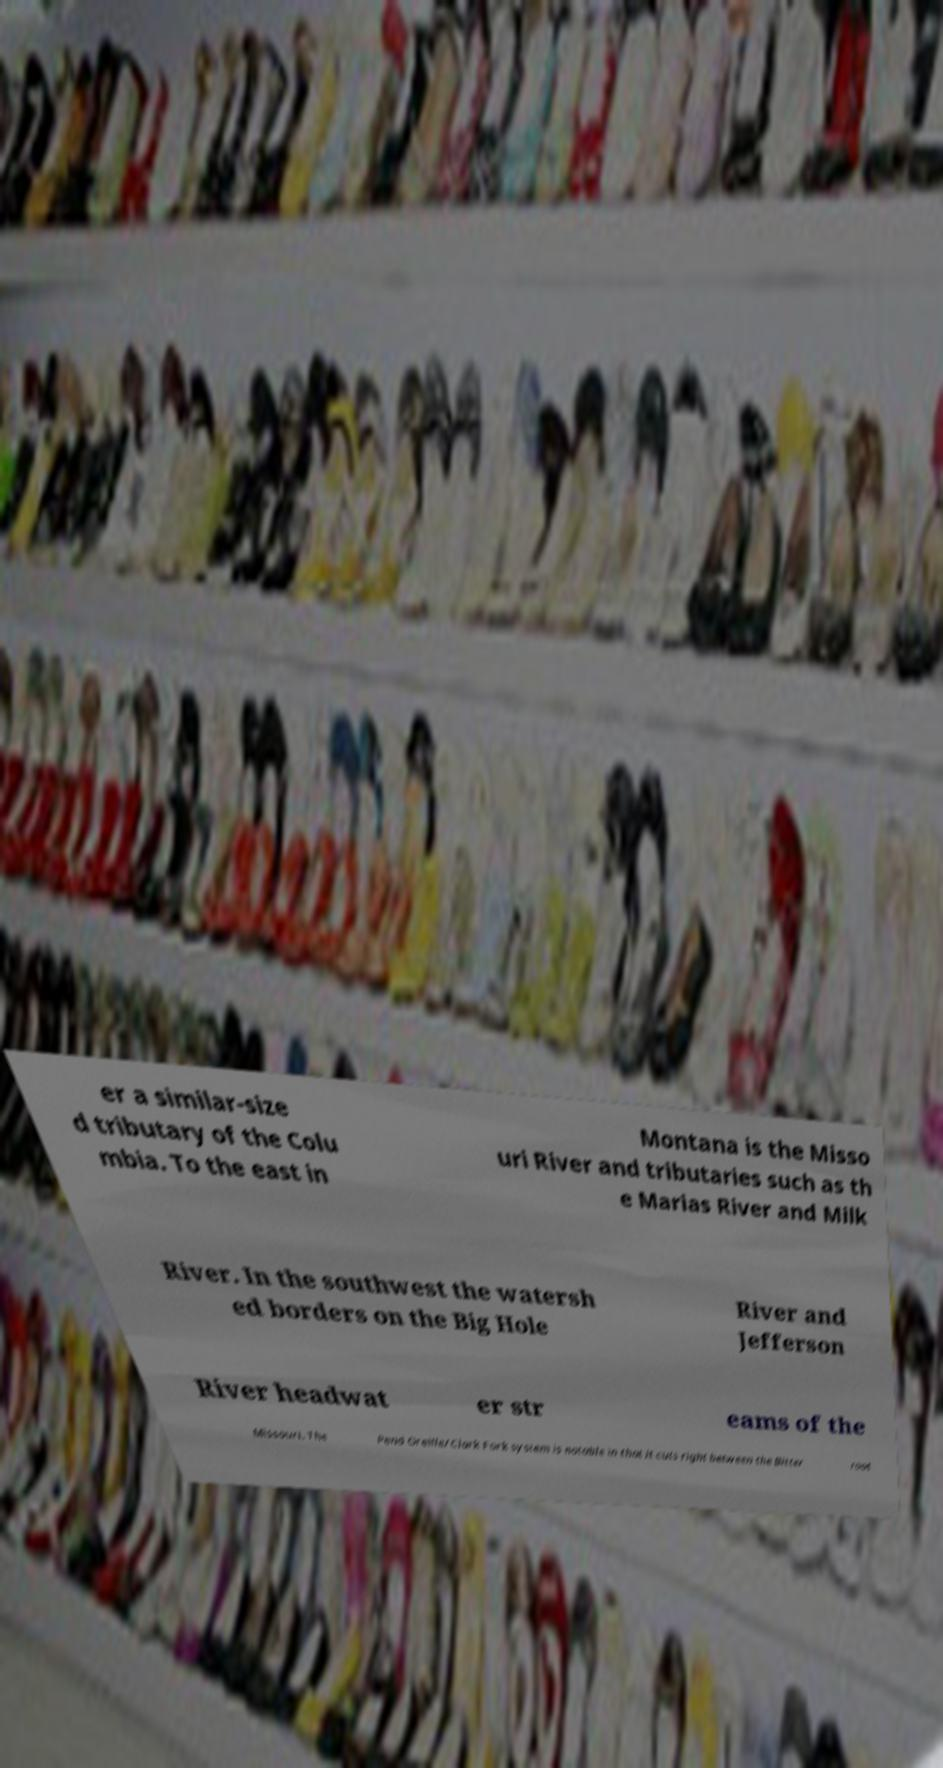Can you read and provide the text displayed in the image?This photo seems to have some interesting text. Can you extract and type it out for me? er a similar-size d tributary of the Colu mbia. To the east in Montana is the Misso uri River and tributaries such as th e Marias River and Milk River. In the southwest the watersh ed borders on the Big Hole River and Jefferson River headwat er str eams of the Missouri. The Pend Oreille/Clark Fork system is notable in that it cuts right between the Bitter root 